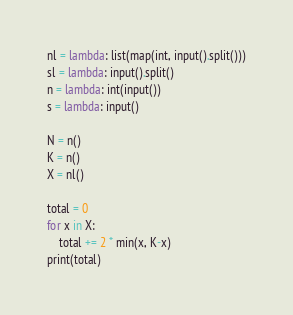Convert code to text. <code><loc_0><loc_0><loc_500><loc_500><_Python_>nl = lambda: list(map(int, input().split()))
sl = lambda: input().split()
n = lambda: int(input())
s = lambda: input()

N = n()
K = n()
X = nl()

total = 0
for x in X:
    total += 2 * min(x, K-x)
print(total)
</code> 